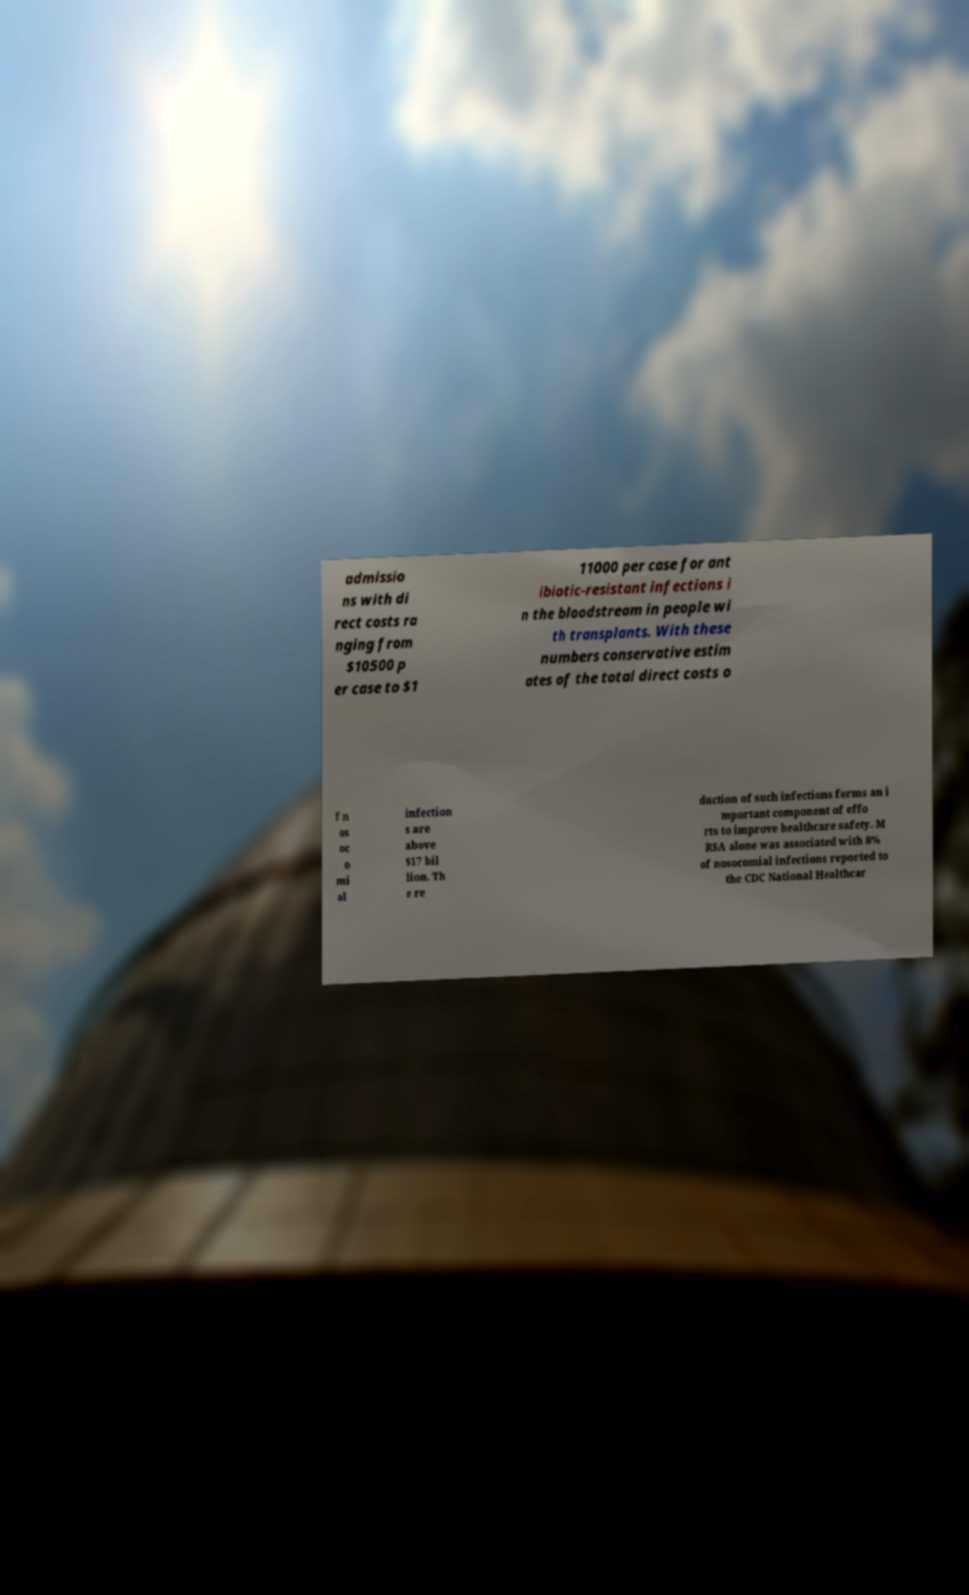There's text embedded in this image that I need extracted. Can you transcribe it verbatim? admissio ns with di rect costs ra nging from $10500 p er case to $1 11000 per case for ant ibiotic-resistant infections i n the bloodstream in people wi th transplants. With these numbers conservative estim ates of the total direct costs o f n os oc o mi al infection s are above $17 bil lion. Th e re duction of such infections forms an i mportant component of effo rts to improve healthcare safety. M RSA alone was associated with 8% of nosocomial infections reported to the CDC National Healthcar 